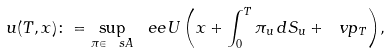<formula> <loc_0><loc_0><loc_500><loc_500>u ( T , x ) \colon = \sup _ { \pi \in \ s A } \ e e { U \left ( x + \int _ { 0 } ^ { T } \pi _ { u } \, d S _ { u } + \ v p _ { T } \right ) } ,</formula> 